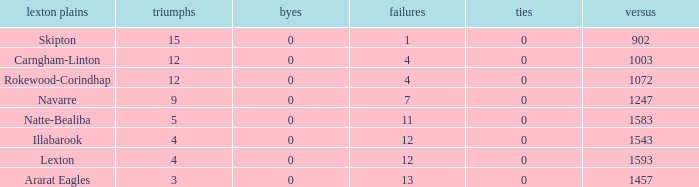What team has fewer than 9 wins and less than 1593 against? Natte-Bealiba, Illabarook, Ararat Eagles. 